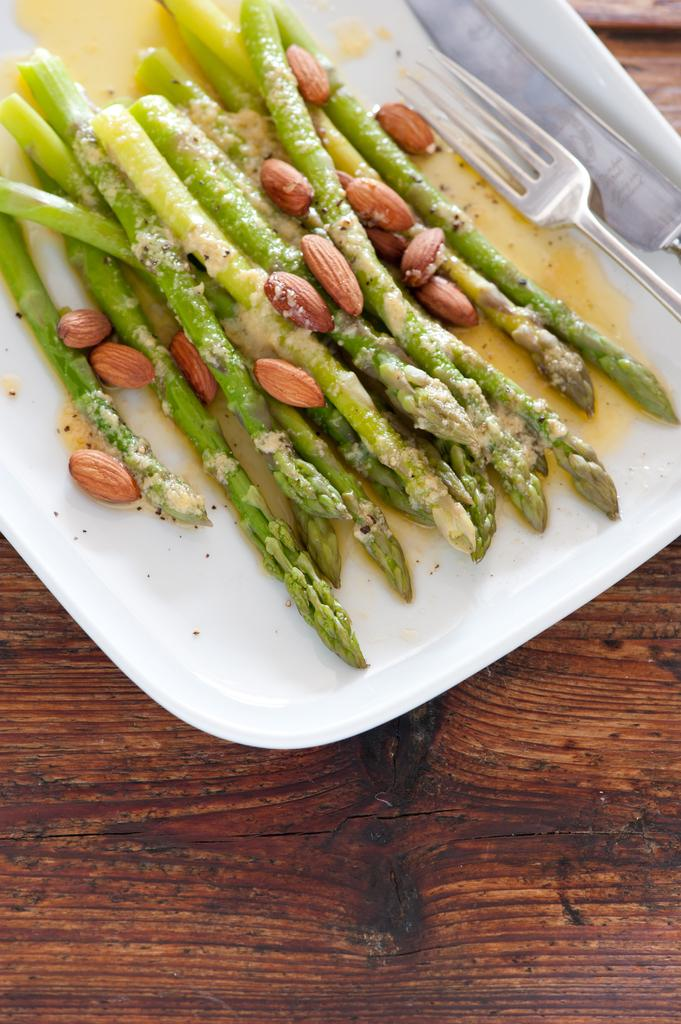What utensils are present in the image? There is a fork and a knife in the image. What is the food item placed on in the image? The food item is placed on a plate in the image. What is the surface on which the plate is placed? The plate is placed on a wooden table. What type of dust can be seen on the apparatus in the image? There is no apparatus or dust present in the image. Is there a crown visible on the food item in the image? There is no crown present on the food item in the image. 